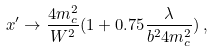Convert formula to latex. <formula><loc_0><loc_0><loc_500><loc_500>x ^ { \prime } \to \frac { 4 m _ { c } ^ { 2 } } { W ^ { 2 } } ( 1 + 0 . 7 5 \frac { \lambda } { b ^ { 2 } 4 m _ { c } ^ { 2 } } ) \, ,</formula> 